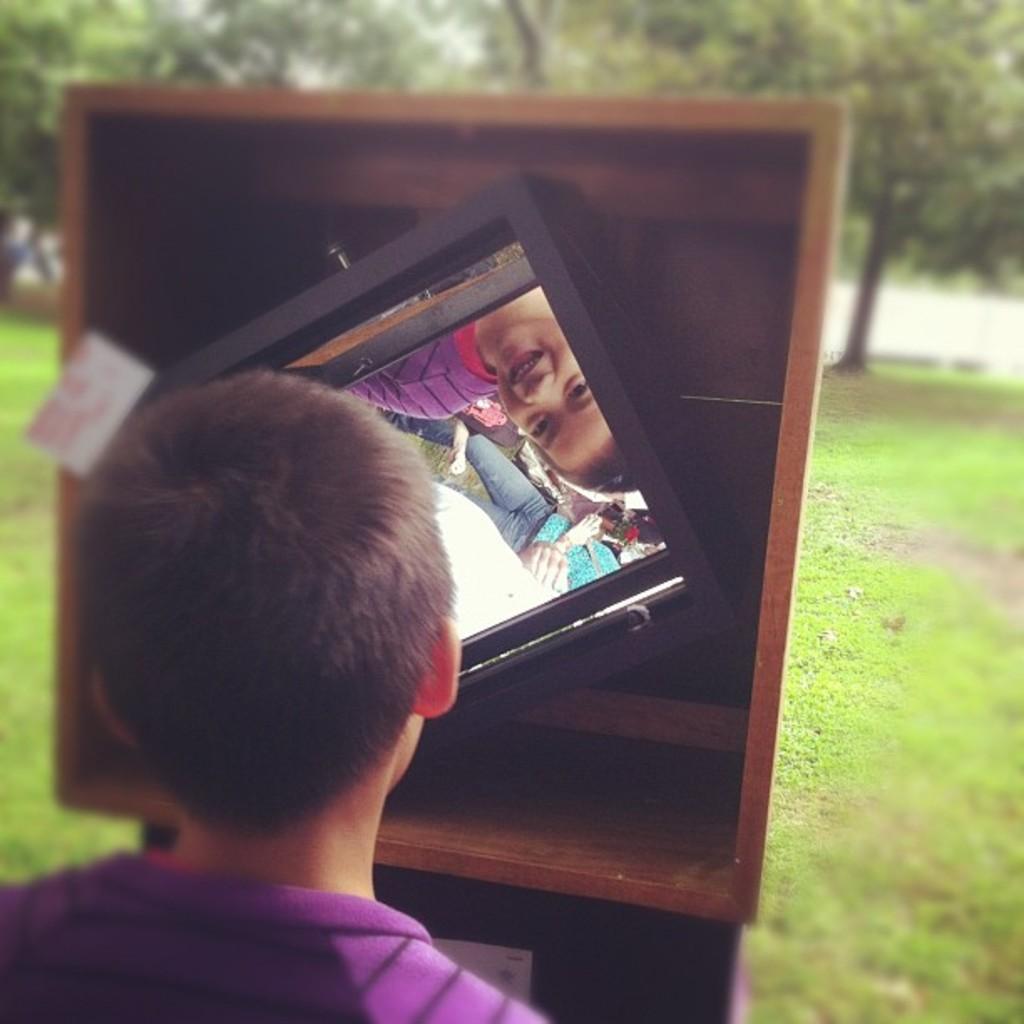Can you describe this image briefly? In this picture there is a small boy looking into the mirror which is placed on the wooden box. Behind there are some trees. 